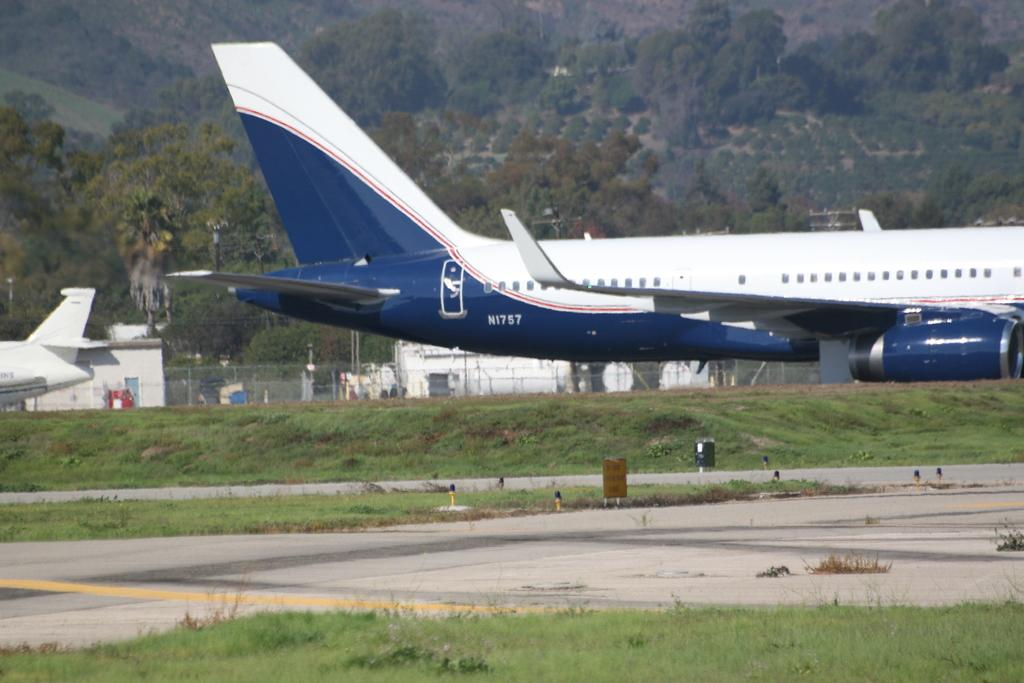<image>
Present a compact description of the photo's key features. A white and blue passenger plane with call sign N1757. 